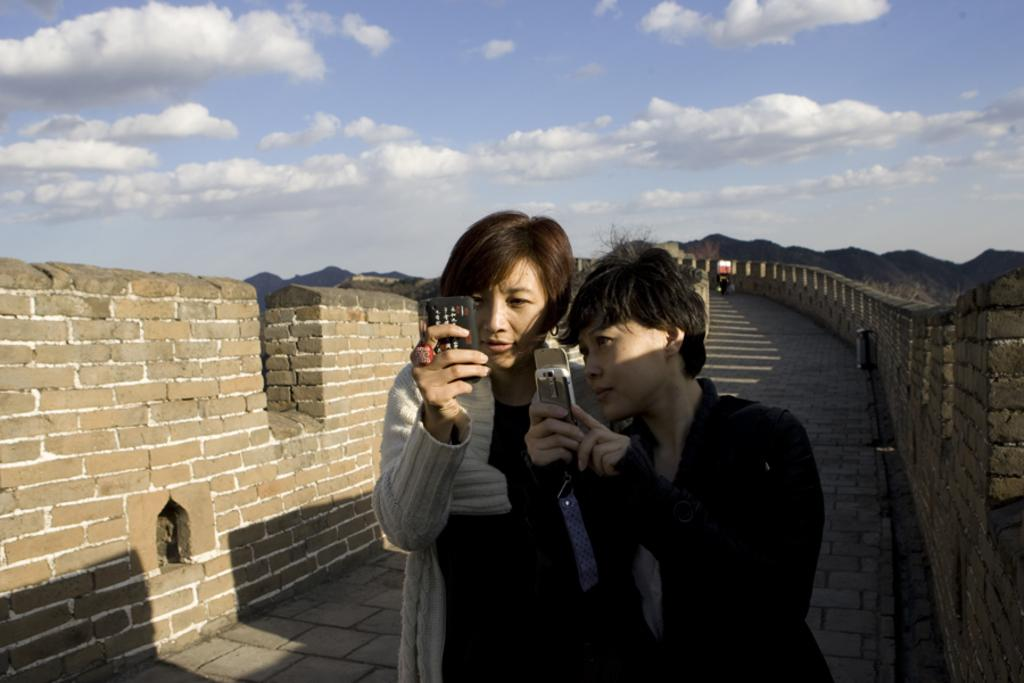How many people are in the image? There are two persons in the image. What are the persons doing in the image? The persons are standing in the image. What are the persons holding in their hands? The persons are holding a mobile phone in their hands. What can be seen on either side of the persons? There is a fence wall on either side of the persons. What is the condition of the sky in the image? The sky is cloudy in the image. What year is depicted in the image? The image does not depict a specific year; it is a photograph of two persons standing with a mobile phone and fence walls. Are the persons in jail in the image? There is no indication in the image that the persons are in jail; they are standing near a fence wall. 